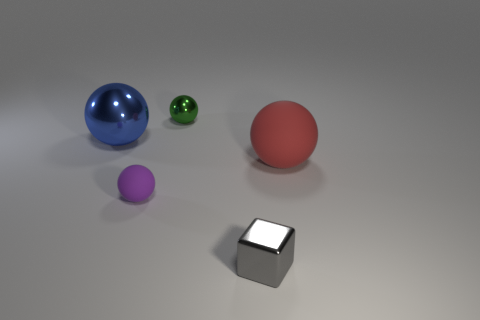Subtract all tiny rubber spheres. How many spheres are left? 3 Add 5 tiny purple shiny cylinders. How many objects exist? 10 Add 2 green spheres. How many green spheres exist? 3 Subtract all green balls. How many balls are left? 3 Subtract 0 brown cylinders. How many objects are left? 5 Subtract all balls. How many objects are left? 1 Subtract 1 balls. How many balls are left? 3 Subtract all cyan balls. Subtract all red cylinders. How many balls are left? 4 Subtract all brown spheres. How many purple blocks are left? 0 Subtract all red objects. Subtract all small metal balls. How many objects are left? 3 